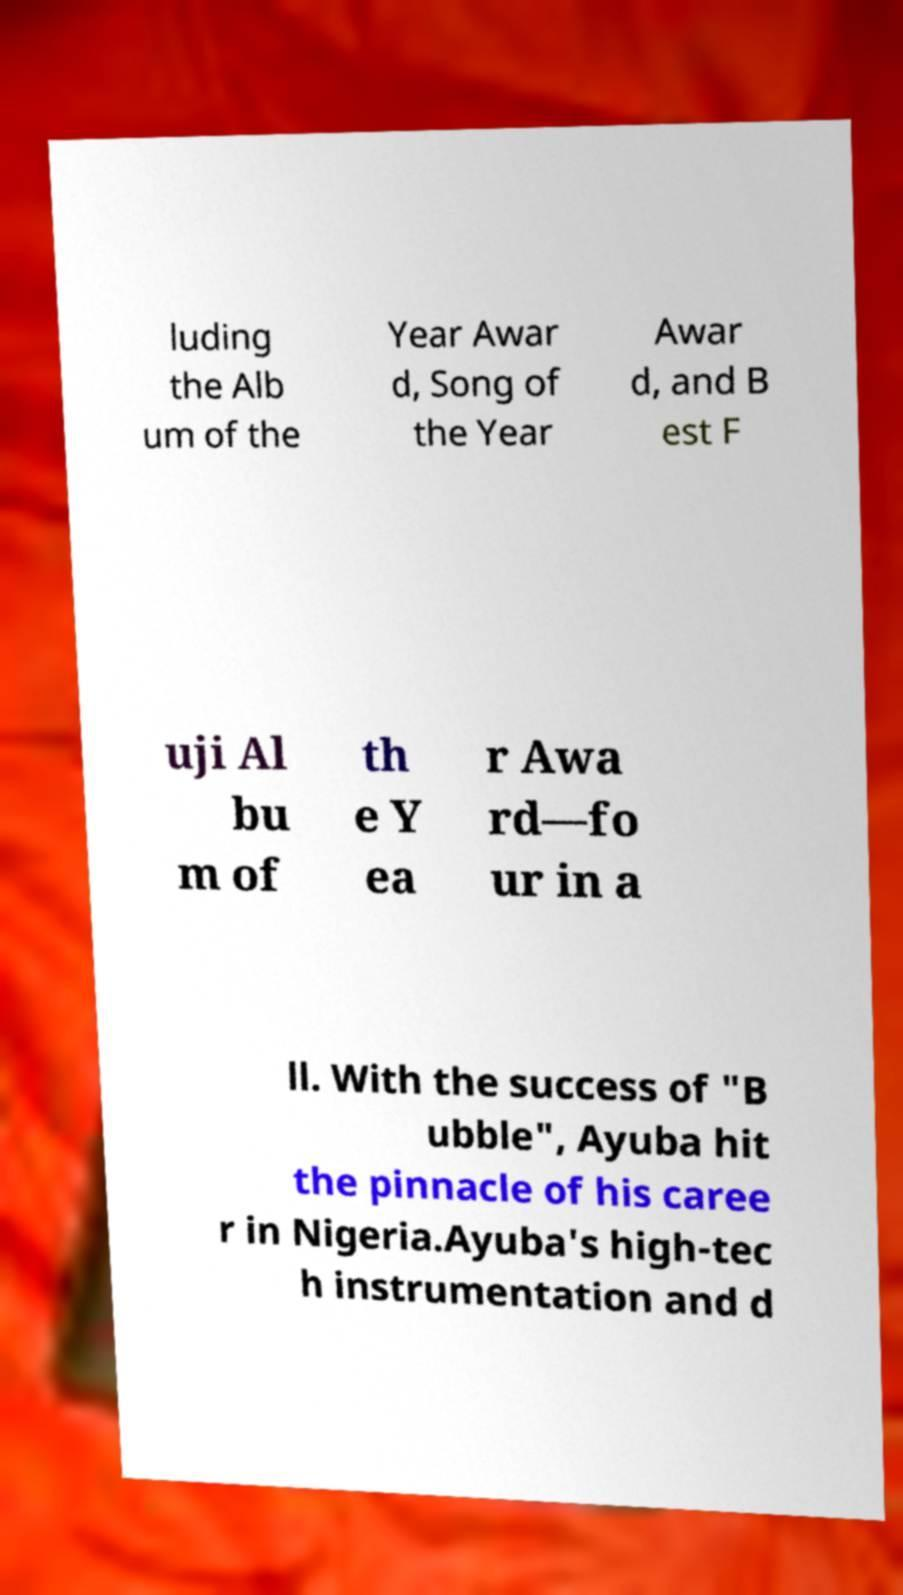What messages or text are displayed in this image? I need them in a readable, typed format. luding the Alb um of the Year Awar d, Song of the Year Awar d, and B est F uji Al bu m of th e Y ea r Awa rd—fo ur in a ll. With the success of "B ubble", Ayuba hit the pinnacle of his caree r in Nigeria.Ayuba's high-tec h instrumentation and d 